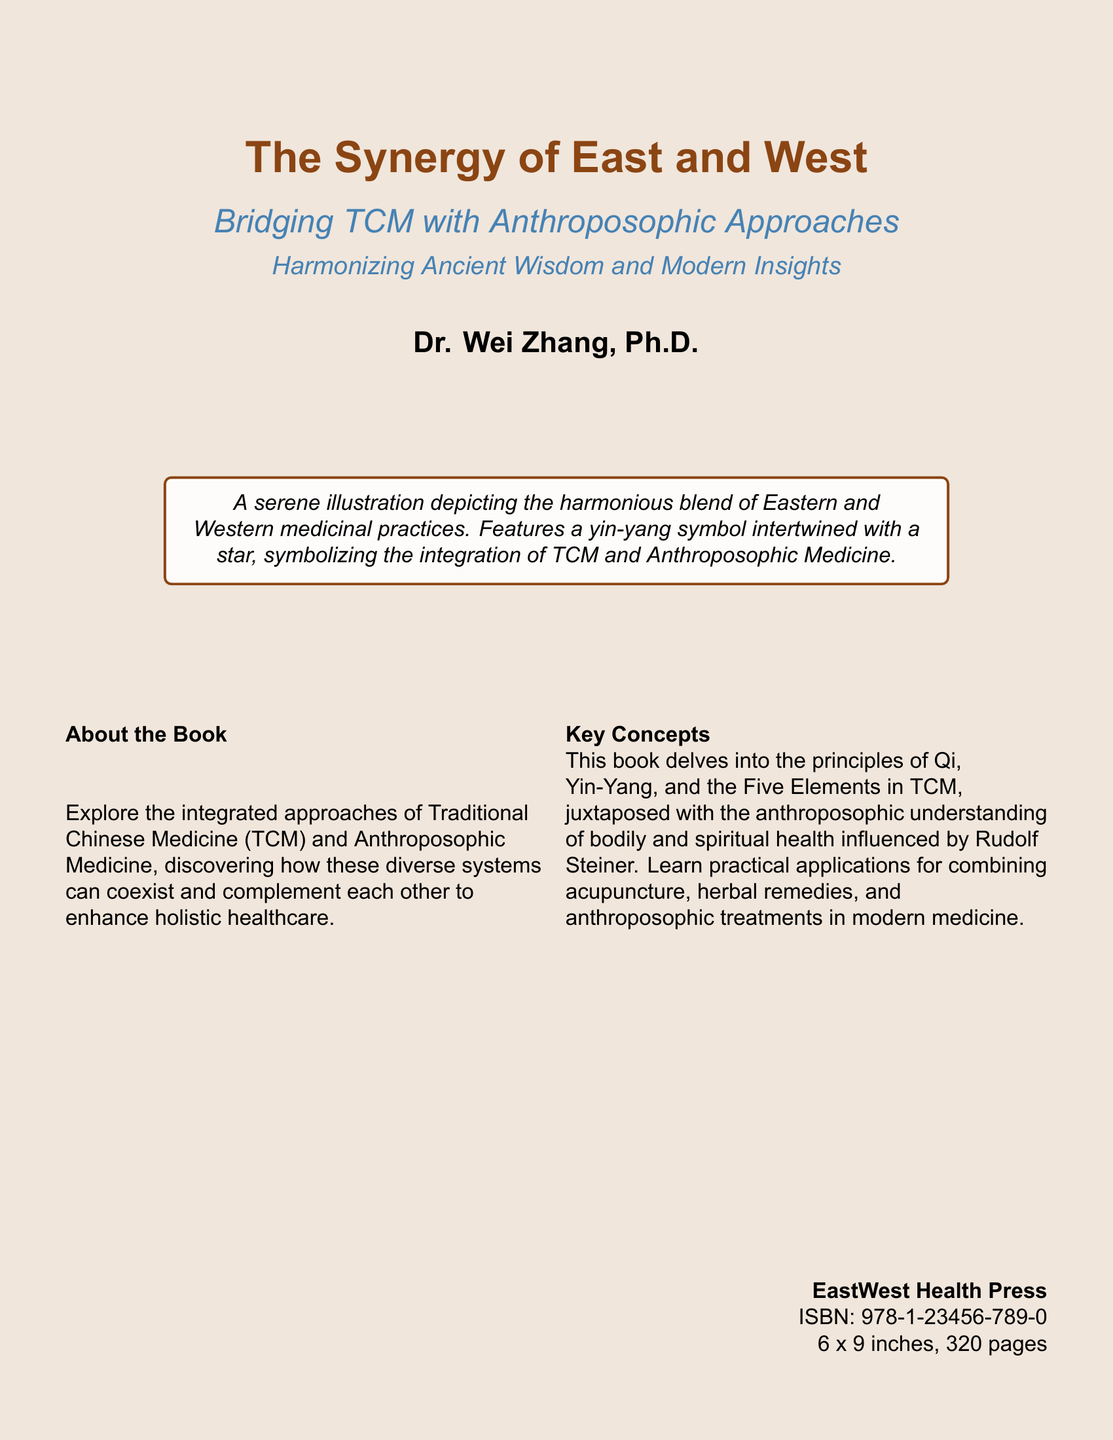What is the title of the book? The title of the book is prominently displayed at the top of the cover.
Answer: The Synergy of East and West Who is the author of the book? The author is listed below the title with Dr. in front of the name.
Answer: Dr. Wei Zhang, Ph.D What is the subtitle of the book? The subtitle is found beneath the title, providing more detail about the content.
Answer: Bridging TCM with Anthroposophic Approaches How many pages does the book have? The total number of pages is stated in the publisher's information at the bottom of the cover.
Answer: 320 pages What type of illustrations are featured on the cover? The cover description mentions specific symbolic illustrations to represent the integration of practices.
Answer: A serene illustration depicting the harmonious blend of Eastern and Western medicinal practices What publisher released this book? The publisher's name is provided at the bottom of the cover.
Answer: EastWest Health Press What is the ISBN of the book? The ISBN is listed in the publication details on the cover.
Answer: 978-1-23456-789-0 What two medicinal practices are integrated in the book? The main focus of the book—Traditional Chinese Medicine and another practice—is mentioned in the overview.
Answer: TCM and Anthroposophic Medicine What holistic concepts are discussed in the book? The book discusses specific principles from TCM that are fundamental to its holistic approach.
Answer: Qi, Yin-Yang, and the Five Elements What approach does the book suggest for combining therapies? The document implies a method of merging practices with TCM and anthroposophic treatments.
Answer: Practical applications for combining acupuncture, herbal remedies, and anthroposophic treatments 